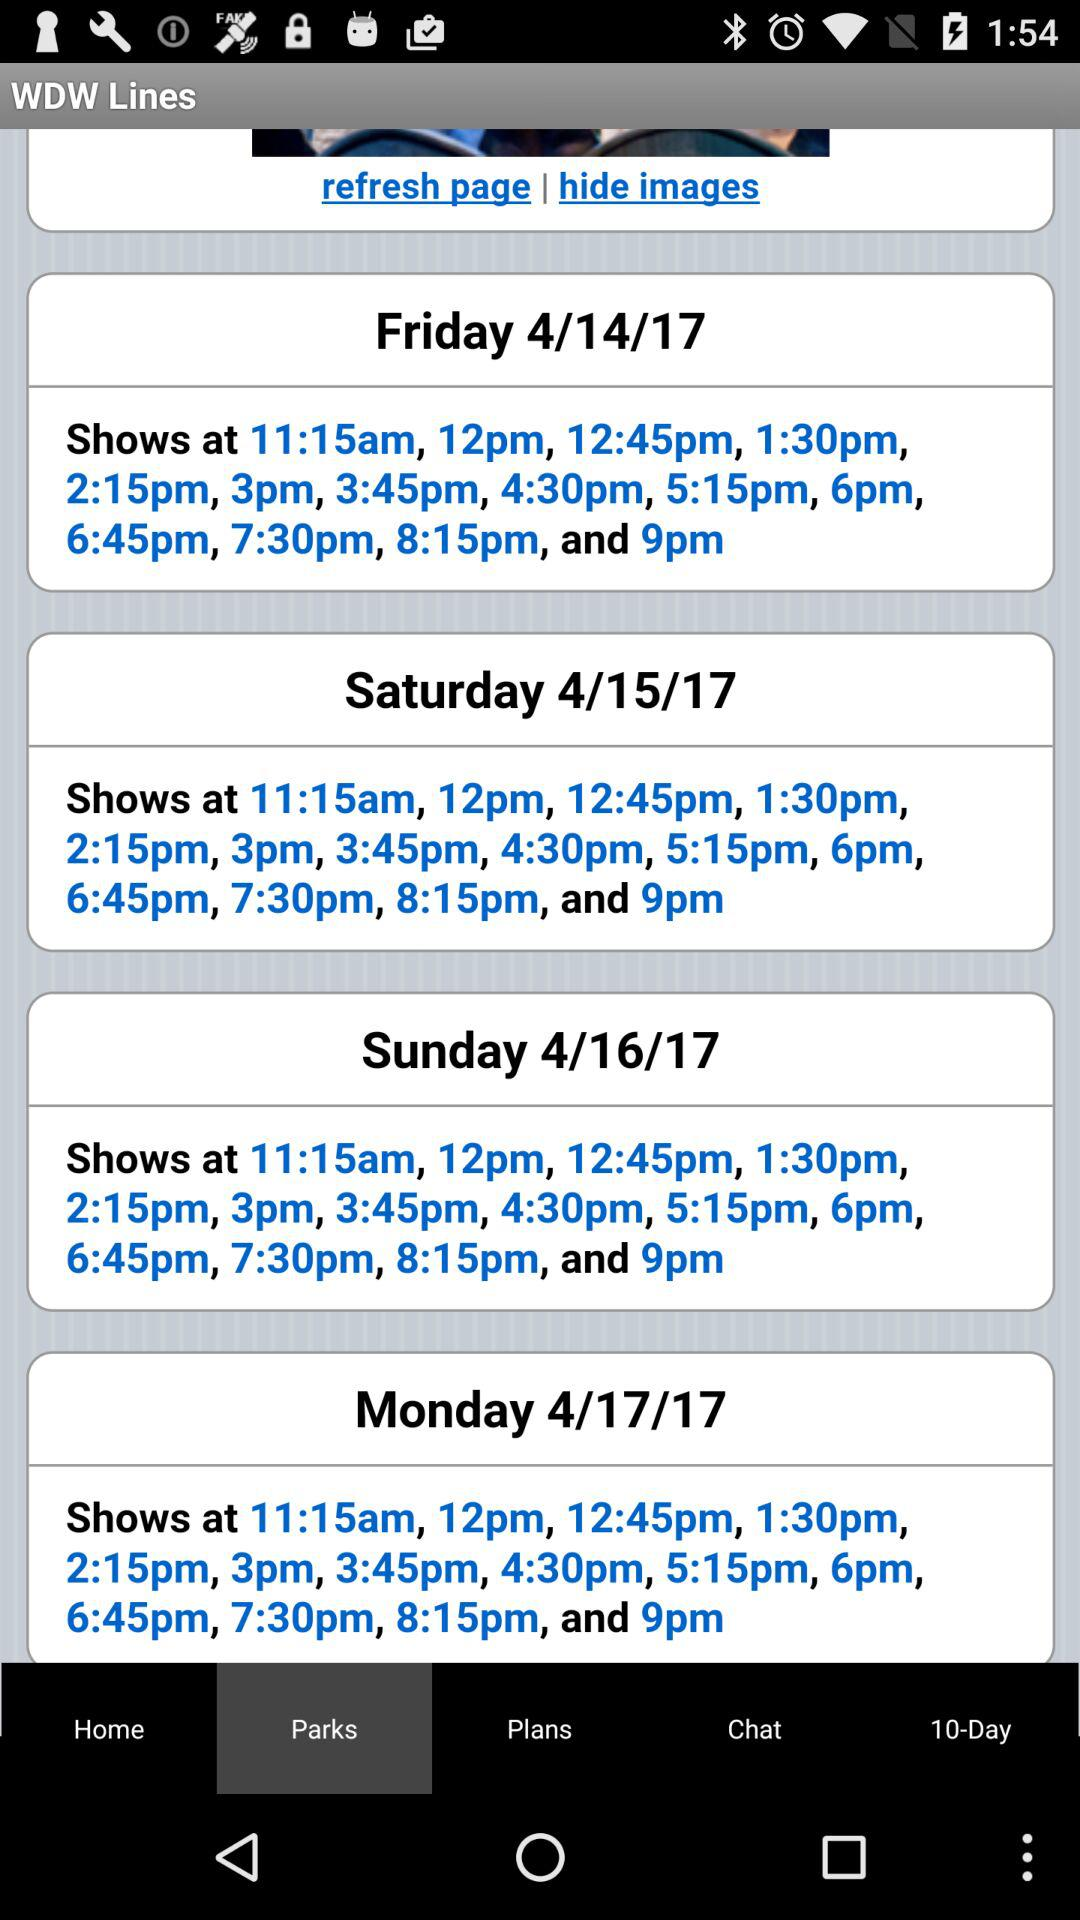What is the show time on Friday? The show times on Friday are 11:15 a.m., 12 p.m., 12:45 p.m., 1:30 p.m., 2:15 p.m., 3 p.m., 3:45 p.m., 4:30 p.m., 5:15 p.m., 6 p.m., 6:45 p.m., 7:30 p.m., 8:15 p.m. and 9 p.m. 